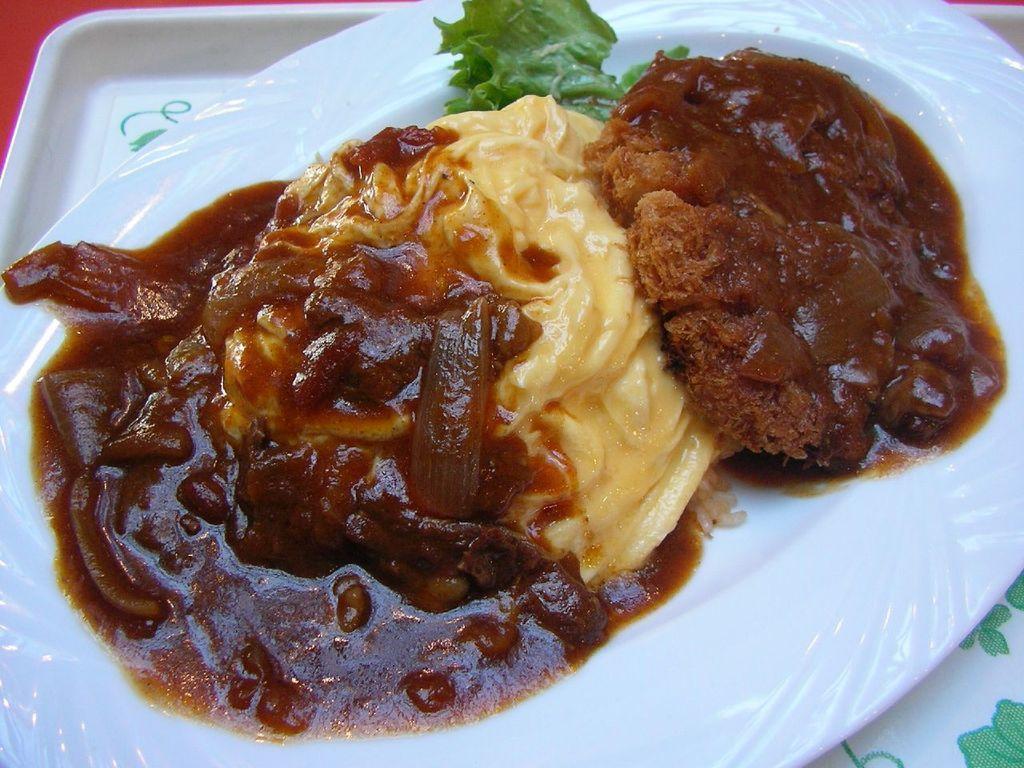In one or two sentences, can you explain what this image depicts? In this image there are food items on the plate. 